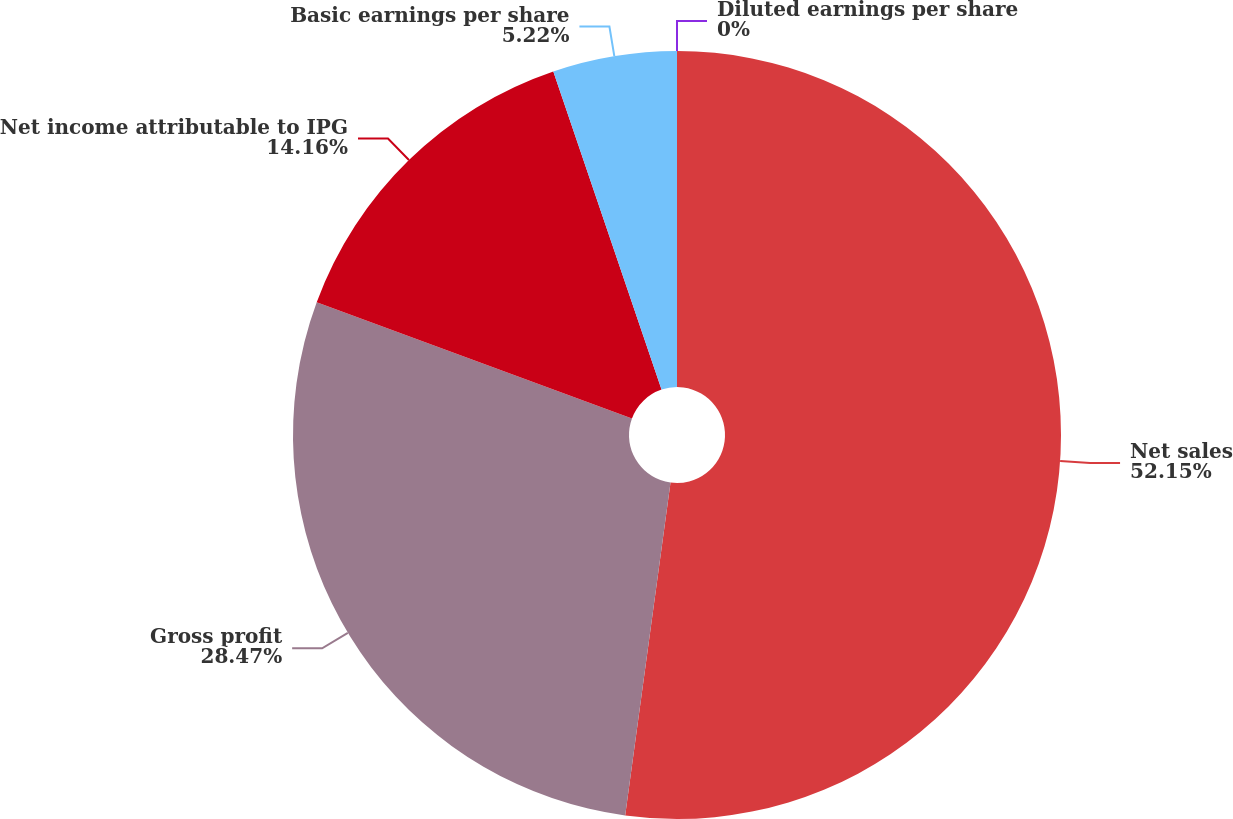Convert chart. <chart><loc_0><loc_0><loc_500><loc_500><pie_chart><fcel>Net sales<fcel>Gross profit<fcel>Net income attributable to IPG<fcel>Basic earnings per share<fcel>Diluted earnings per share<nl><fcel>52.16%<fcel>28.47%<fcel>14.16%<fcel>5.22%<fcel>0.0%<nl></chart> 